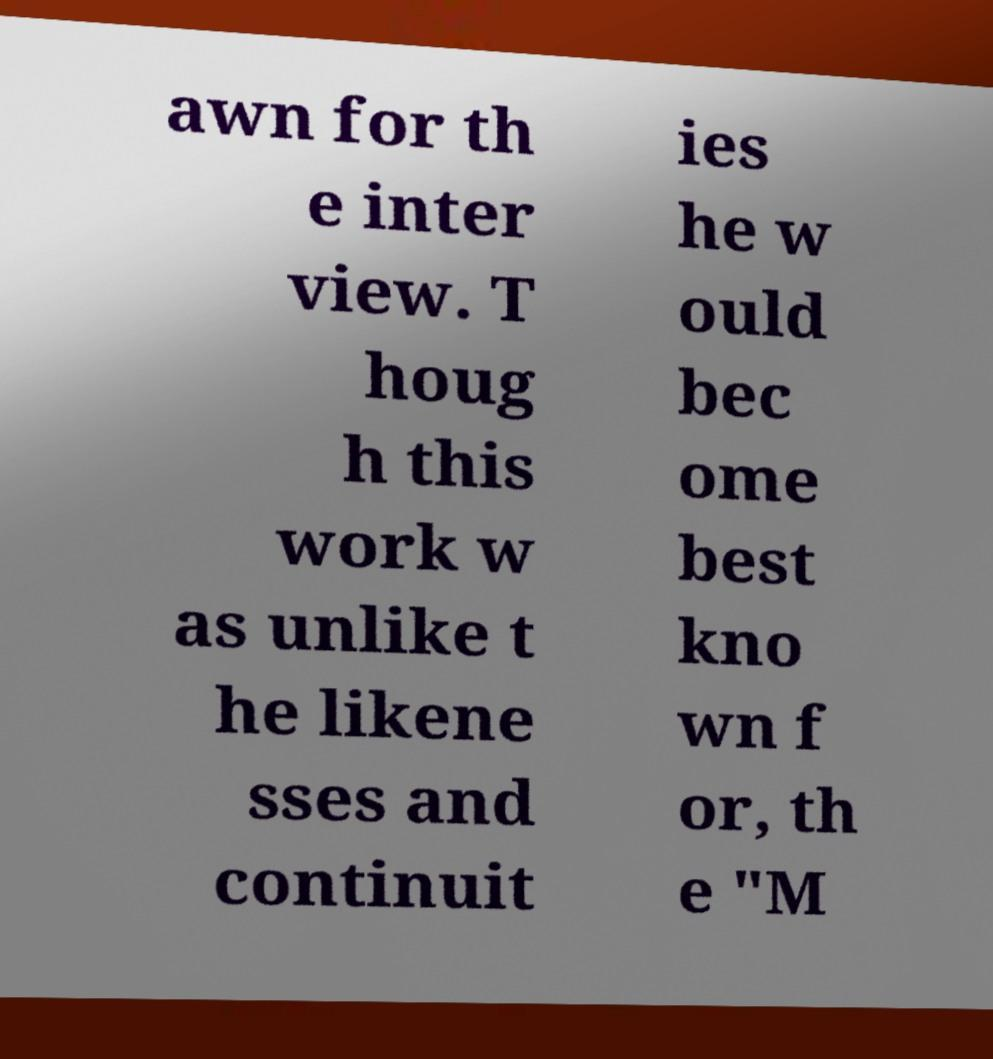Could you assist in decoding the text presented in this image and type it out clearly? awn for th e inter view. T houg h this work w as unlike t he likene sses and continuit ies he w ould bec ome best kno wn f or, th e "M 